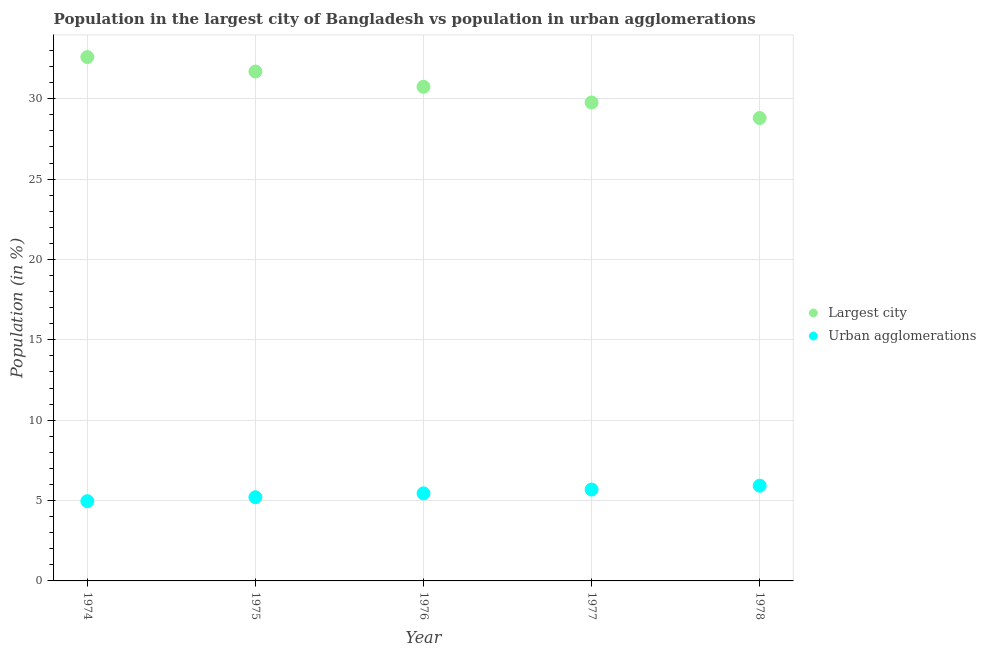Is the number of dotlines equal to the number of legend labels?
Ensure brevity in your answer.  Yes. What is the population in the largest city in 1977?
Provide a succinct answer. 29.77. Across all years, what is the maximum population in the largest city?
Your response must be concise. 32.59. Across all years, what is the minimum population in urban agglomerations?
Your answer should be compact. 4.96. In which year was the population in the largest city maximum?
Make the answer very short. 1974. In which year was the population in the largest city minimum?
Your answer should be very brief. 1978. What is the total population in urban agglomerations in the graph?
Ensure brevity in your answer.  27.22. What is the difference between the population in urban agglomerations in 1975 and that in 1976?
Provide a succinct answer. -0.24. What is the difference between the population in urban agglomerations in 1978 and the population in the largest city in 1977?
Keep it short and to the point. -23.84. What is the average population in the largest city per year?
Ensure brevity in your answer.  30.72. In the year 1977, what is the difference between the population in urban agglomerations and population in the largest city?
Your response must be concise. -24.08. What is the ratio of the population in urban agglomerations in 1974 to that in 1975?
Provide a short and direct response. 0.95. What is the difference between the highest and the second highest population in urban agglomerations?
Provide a succinct answer. 0.24. What is the difference between the highest and the lowest population in urban agglomerations?
Provide a succinct answer. 0.96. In how many years, is the population in the largest city greater than the average population in the largest city taken over all years?
Your response must be concise. 3. Does the population in urban agglomerations monotonically increase over the years?
Your response must be concise. Yes. Is the population in the largest city strictly greater than the population in urban agglomerations over the years?
Offer a terse response. Yes. Is the population in urban agglomerations strictly less than the population in the largest city over the years?
Provide a short and direct response. Yes. How many dotlines are there?
Offer a terse response. 2. What is the difference between two consecutive major ticks on the Y-axis?
Keep it short and to the point. 5. Does the graph contain grids?
Provide a succinct answer. Yes. How many legend labels are there?
Provide a short and direct response. 2. How are the legend labels stacked?
Your answer should be very brief. Vertical. What is the title of the graph?
Ensure brevity in your answer.  Population in the largest city of Bangladesh vs population in urban agglomerations. What is the label or title of the X-axis?
Your answer should be compact. Year. What is the label or title of the Y-axis?
Make the answer very short. Population (in %). What is the Population (in %) in Largest city in 1974?
Ensure brevity in your answer.  32.59. What is the Population (in %) of Urban agglomerations in 1974?
Offer a very short reply. 4.96. What is the Population (in %) of Largest city in 1975?
Provide a short and direct response. 31.69. What is the Population (in %) of Urban agglomerations in 1975?
Your answer should be compact. 5.21. What is the Population (in %) of Largest city in 1976?
Your response must be concise. 30.74. What is the Population (in %) in Urban agglomerations in 1976?
Ensure brevity in your answer.  5.45. What is the Population (in %) in Largest city in 1977?
Your response must be concise. 29.77. What is the Population (in %) of Urban agglomerations in 1977?
Provide a short and direct response. 5.69. What is the Population (in %) in Largest city in 1978?
Provide a short and direct response. 28.8. What is the Population (in %) in Urban agglomerations in 1978?
Offer a terse response. 5.92. Across all years, what is the maximum Population (in %) in Largest city?
Offer a very short reply. 32.59. Across all years, what is the maximum Population (in %) of Urban agglomerations?
Your response must be concise. 5.92. Across all years, what is the minimum Population (in %) of Largest city?
Your response must be concise. 28.8. Across all years, what is the minimum Population (in %) of Urban agglomerations?
Provide a short and direct response. 4.96. What is the total Population (in %) in Largest city in the graph?
Your answer should be compact. 153.6. What is the total Population (in %) of Urban agglomerations in the graph?
Ensure brevity in your answer.  27.22. What is the difference between the Population (in %) in Largest city in 1974 and that in 1975?
Keep it short and to the point. 0.9. What is the difference between the Population (in %) in Urban agglomerations in 1974 and that in 1975?
Ensure brevity in your answer.  -0.25. What is the difference between the Population (in %) in Largest city in 1974 and that in 1976?
Make the answer very short. 1.85. What is the difference between the Population (in %) of Urban agglomerations in 1974 and that in 1976?
Your answer should be very brief. -0.49. What is the difference between the Population (in %) of Largest city in 1974 and that in 1977?
Your answer should be very brief. 2.82. What is the difference between the Population (in %) of Urban agglomerations in 1974 and that in 1977?
Ensure brevity in your answer.  -0.72. What is the difference between the Population (in %) in Largest city in 1974 and that in 1978?
Provide a succinct answer. 3.79. What is the difference between the Population (in %) of Urban agglomerations in 1974 and that in 1978?
Keep it short and to the point. -0.96. What is the difference between the Population (in %) in Largest city in 1975 and that in 1976?
Provide a succinct answer. 0.95. What is the difference between the Population (in %) of Urban agglomerations in 1975 and that in 1976?
Make the answer very short. -0.24. What is the difference between the Population (in %) of Largest city in 1975 and that in 1977?
Provide a short and direct response. 1.93. What is the difference between the Population (in %) in Urban agglomerations in 1975 and that in 1977?
Give a very brief answer. -0.48. What is the difference between the Population (in %) in Largest city in 1975 and that in 1978?
Give a very brief answer. 2.89. What is the difference between the Population (in %) of Urban agglomerations in 1975 and that in 1978?
Your answer should be very brief. -0.72. What is the difference between the Population (in %) in Largest city in 1976 and that in 1977?
Ensure brevity in your answer.  0.98. What is the difference between the Population (in %) in Urban agglomerations in 1976 and that in 1977?
Provide a succinct answer. -0.24. What is the difference between the Population (in %) in Largest city in 1976 and that in 1978?
Provide a succinct answer. 1.94. What is the difference between the Population (in %) in Urban agglomerations in 1976 and that in 1978?
Your answer should be compact. -0.48. What is the difference between the Population (in %) of Largest city in 1977 and that in 1978?
Provide a succinct answer. 0.97. What is the difference between the Population (in %) in Urban agglomerations in 1977 and that in 1978?
Your response must be concise. -0.24. What is the difference between the Population (in %) in Largest city in 1974 and the Population (in %) in Urban agglomerations in 1975?
Keep it short and to the point. 27.39. What is the difference between the Population (in %) in Largest city in 1974 and the Population (in %) in Urban agglomerations in 1976?
Give a very brief answer. 27.14. What is the difference between the Population (in %) in Largest city in 1974 and the Population (in %) in Urban agglomerations in 1977?
Provide a succinct answer. 26.91. What is the difference between the Population (in %) in Largest city in 1974 and the Population (in %) in Urban agglomerations in 1978?
Your answer should be very brief. 26.67. What is the difference between the Population (in %) of Largest city in 1975 and the Population (in %) of Urban agglomerations in 1976?
Your answer should be compact. 26.25. What is the difference between the Population (in %) in Largest city in 1975 and the Population (in %) in Urban agglomerations in 1977?
Your response must be concise. 26.01. What is the difference between the Population (in %) of Largest city in 1975 and the Population (in %) of Urban agglomerations in 1978?
Ensure brevity in your answer.  25.77. What is the difference between the Population (in %) in Largest city in 1976 and the Population (in %) in Urban agglomerations in 1977?
Provide a short and direct response. 25.06. What is the difference between the Population (in %) in Largest city in 1976 and the Population (in %) in Urban agglomerations in 1978?
Give a very brief answer. 24.82. What is the difference between the Population (in %) of Largest city in 1977 and the Population (in %) of Urban agglomerations in 1978?
Keep it short and to the point. 23.84. What is the average Population (in %) in Largest city per year?
Provide a succinct answer. 30.72. What is the average Population (in %) in Urban agglomerations per year?
Your answer should be very brief. 5.44. In the year 1974, what is the difference between the Population (in %) of Largest city and Population (in %) of Urban agglomerations?
Provide a short and direct response. 27.63. In the year 1975, what is the difference between the Population (in %) of Largest city and Population (in %) of Urban agglomerations?
Offer a very short reply. 26.49. In the year 1976, what is the difference between the Population (in %) of Largest city and Population (in %) of Urban agglomerations?
Provide a short and direct response. 25.29. In the year 1977, what is the difference between the Population (in %) in Largest city and Population (in %) in Urban agglomerations?
Make the answer very short. 24.08. In the year 1978, what is the difference between the Population (in %) in Largest city and Population (in %) in Urban agglomerations?
Offer a terse response. 22.88. What is the ratio of the Population (in %) in Largest city in 1974 to that in 1975?
Give a very brief answer. 1.03. What is the ratio of the Population (in %) in Urban agglomerations in 1974 to that in 1975?
Your response must be concise. 0.95. What is the ratio of the Population (in %) of Largest city in 1974 to that in 1976?
Ensure brevity in your answer.  1.06. What is the ratio of the Population (in %) in Urban agglomerations in 1974 to that in 1976?
Keep it short and to the point. 0.91. What is the ratio of the Population (in %) of Largest city in 1974 to that in 1977?
Provide a short and direct response. 1.09. What is the ratio of the Population (in %) in Urban agglomerations in 1974 to that in 1977?
Your answer should be compact. 0.87. What is the ratio of the Population (in %) of Largest city in 1974 to that in 1978?
Offer a terse response. 1.13. What is the ratio of the Population (in %) in Urban agglomerations in 1974 to that in 1978?
Ensure brevity in your answer.  0.84. What is the ratio of the Population (in %) in Largest city in 1975 to that in 1976?
Provide a short and direct response. 1.03. What is the ratio of the Population (in %) in Urban agglomerations in 1975 to that in 1976?
Provide a short and direct response. 0.96. What is the ratio of the Population (in %) of Largest city in 1975 to that in 1977?
Ensure brevity in your answer.  1.06. What is the ratio of the Population (in %) of Urban agglomerations in 1975 to that in 1977?
Provide a short and direct response. 0.92. What is the ratio of the Population (in %) of Largest city in 1975 to that in 1978?
Make the answer very short. 1.1. What is the ratio of the Population (in %) in Urban agglomerations in 1975 to that in 1978?
Your answer should be very brief. 0.88. What is the ratio of the Population (in %) in Largest city in 1976 to that in 1977?
Your answer should be compact. 1.03. What is the ratio of the Population (in %) of Largest city in 1976 to that in 1978?
Ensure brevity in your answer.  1.07. What is the ratio of the Population (in %) in Urban agglomerations in 1976 to that in 1978?
Offer a terse response. 0.92. What is the ratio of the Population (in %) in Largest city in 1977 to that in 1978?
Your answer should be very brief. 1.03. What is the ratio of the Population (in %) in Urban agglomerations in 1977 to that in 1978?
Provide a succinct answer. 0.96. What is the difference between the highest and the second highest Population (in %) of Largest city?
Provide a short and direct response. 0.9. What is the difference between the highest and the second highest Population (in %) in Urban agglomerations?
Provide a succinct answer. 0.24. What is the difference between the highest and the lowest Population (in %) in Largest city?
Give a very brief answer. 3.79. What is the difference between the highest and the lowest Population (in %) in Urban agglomerations?
Offer a very short reply. 0.96. 